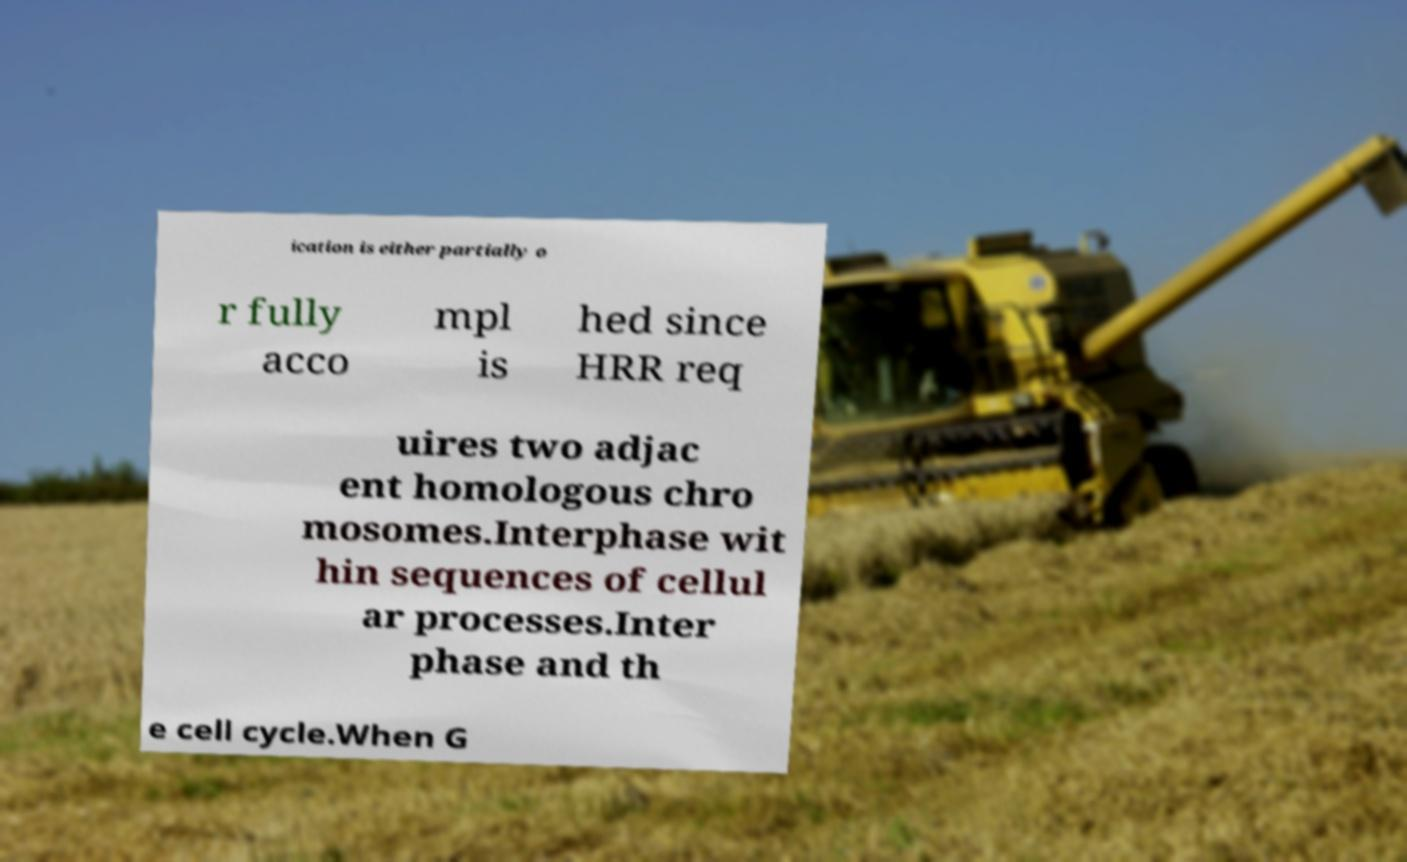There's text embedded in this image that I need extracted. Can you transcribe it verbatim? ication is either partially o r fully acco mpl is hed since HRR req uires two adjac ent homologous chro mosomes.Interphase wit hin sequences of cellul ar processes.Inter phase and th e cell cycle.When G 